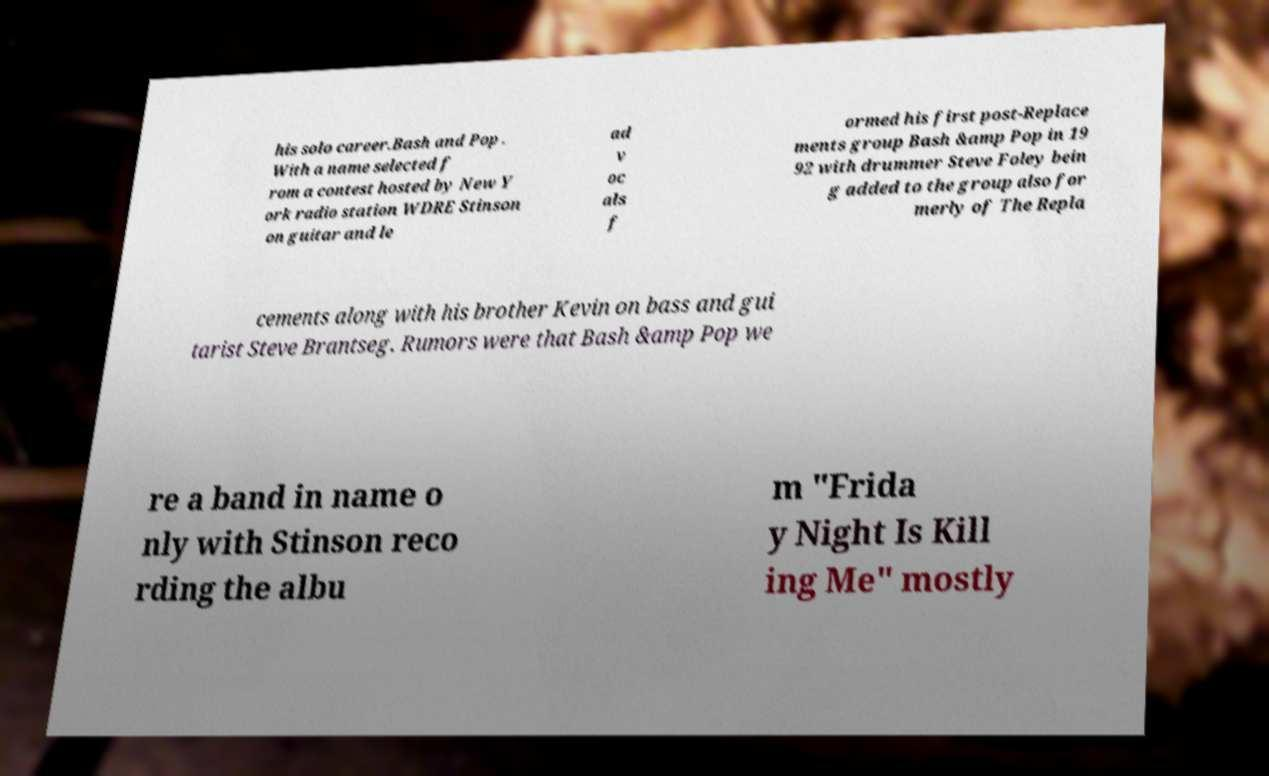Can you accurately transcribe the text from the provided image for me? his solo career.Bash and Pop . With a name selected f rom a contest hosted by New Y ork radio station WDRE Stinson on guitar and le ad v oc als f ormed his first post-Replace ments group Bash &amp Pop in 19 92 with drummer Steve Foley bein g added to the group also for merly of The Repla cements along with his brother Kevin on bass and gui tarist Steve Brantseg. Rumors were that Bash &amp Pop we re a band in name o nly with Stinson reco rding the albu m "Frida y Night Is Kill ing Me" mostly 